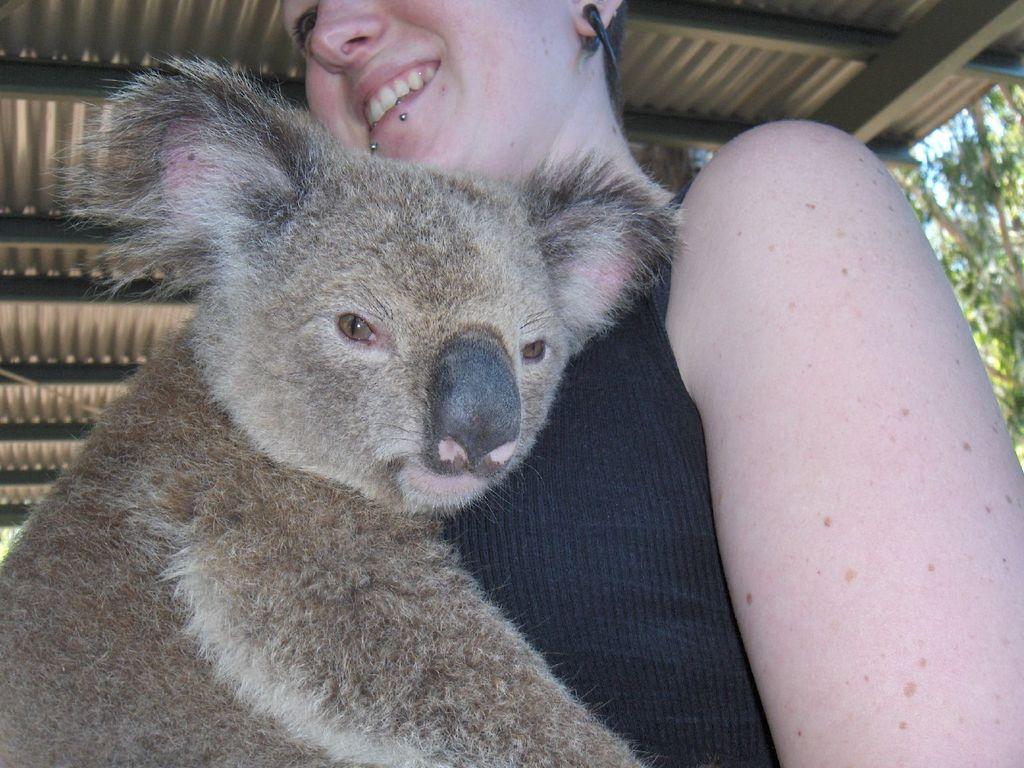Please provide a concise description of this image. In the foreground of this image, there is koala and a woman under the shed like structure and in the background, there are trees. 